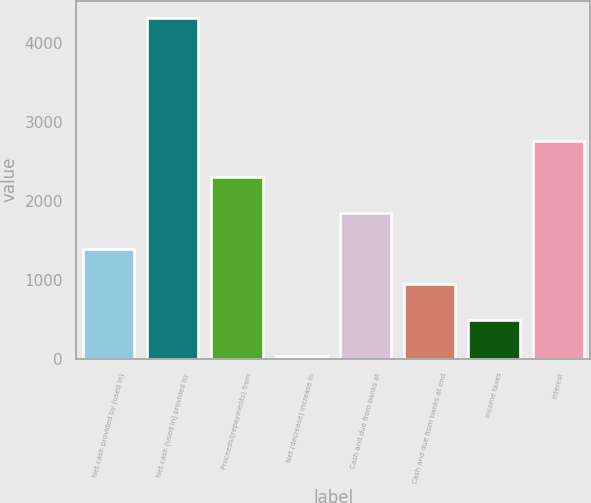Convert chart. <chart><loc_0><loc_0><loc_500><loc_500><bar_chart><fcel>Net cash provided by (used in)<fcel>Net cash (used in) provided by<fcel>Proceeds/(repayments) from<fcel>Net (decrease) increase in<fcel>Cash and due from banks at<fcel>Cash and due from banks at end<fcel>Income taxes<fcel>Interest<nl><fcel>1399<fcel>4325<fcel>2311<fcel>31<fcel>1855<fcel>943<fcel>487<fcel>2767<nl></chart> 